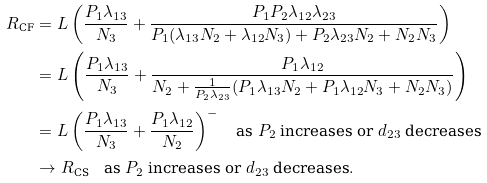<formula> <loc_0><loc_0><loc_500><loc_500>R _ { \text {CF} } & = L \left ( \frac { P _ { 1 } \lambda _ { 1 3 } } { N _ { 3 } } + \frac { P _ { 1 } P _ { 2 } \lambda _ { 1 2 } \lambda _ { 2 3 } } { P _ { 1 } ( \lambda _ { 1 3 } N _ { 2 } + \lambda _ { 1 2 } N _ { 3 } ) + P _ { 2 } \lambda _ { 2 3 } N _ { 2 } + N _ { 2 } N _ { 3 } } \right ) \\ & = L \left ( \frac { P _ { 1 } \lambda _ { 1 3 } } { N _ { 3 } } + \frac { P _ { 1 } \lambda _ { 1 2 } } { N _ { 2 } + \frac { 1 } { P _ { 2 } \lambda _ { 2 3 } } ( P _ { 1 } \lambda _ { 1 3 } N _ { 2 } + P _ { 1 } \lambda _ { 1 2 } N _ { 3 } + N _ { 2 } N _ { 3 } ) } \right ) \\ & = L \left ( \frac { P _ { 1 } \lambda _ { 1 3 } } { N _ { 3 } } + \frac { P _ { 1 } \lambda _ { 1 2 } } { N _ { 2 } } \right ) ^ { - } \quad \text {as $P_{2}$ increases or $d_{23}$ decreases} \\ & \rightarrow R _ { \text {CS} } \quad \text {as $P_{2}$ increases or $d_{23}$ decreases} .</formula> 